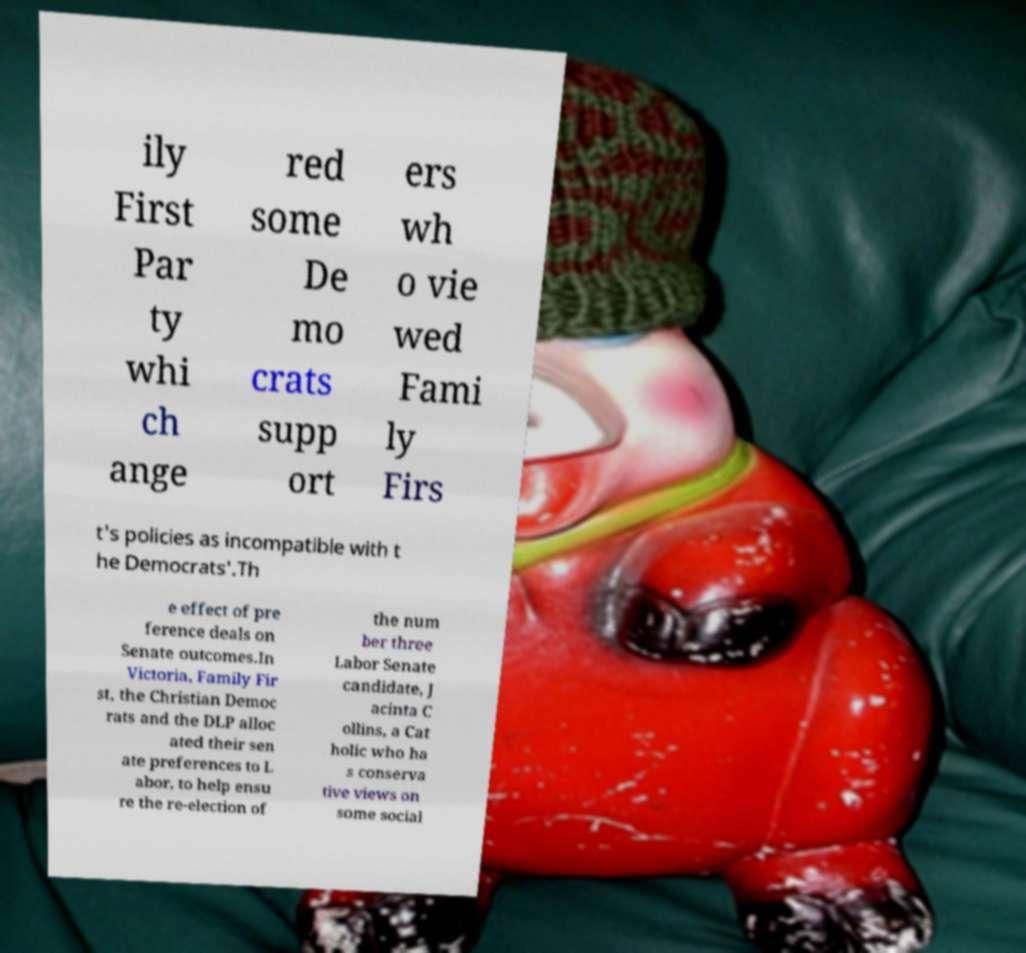Please identify and transcribe the text found in this image. ily First Par ty whi ch ange red some De mo crats supp ort ers wh o vie wed Fami ly Firs t's policies as incompatible with t he Democrats'.Th e effect of pre ference deals on Senate outcomes.In Victoria, Family Fir st, the Christian Democ rats and the DLP alloc ated their sen ate preferences to L abor, to help ensu re the re-election of the num ber three Labor Senate candidate, J acinta C ollins, a Cat holic who ha s conserva tive views on some social 